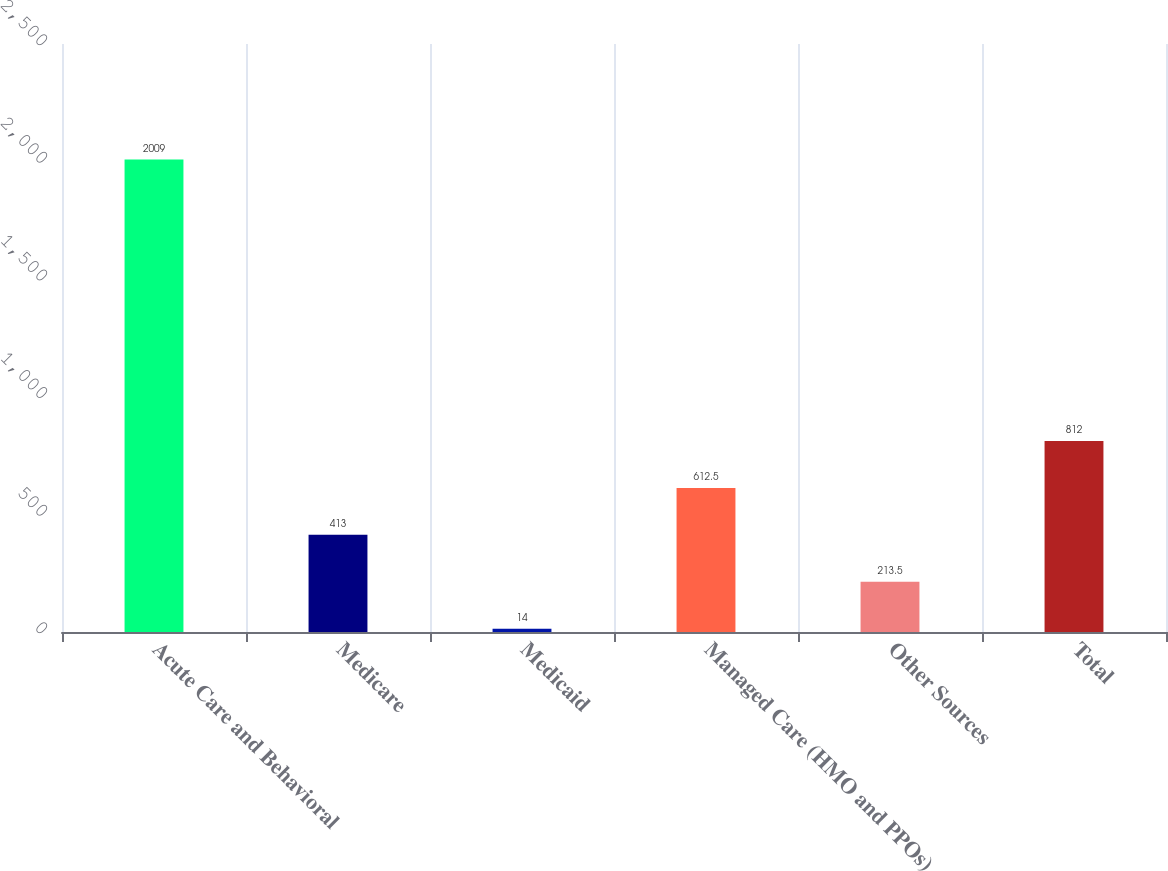Convert chart. <chart><loc_0><loc_0><loc_500><loc_500><bar_chart><fcel>Acute Care and Behavioral<fcel>Medicare<fcel>Medicaid<fcel>Managed Care (HMO and PPOs)<fcel>Other Sources<fcel>Total<nl><fcel>2009<fcel>413<fcel>14<fcel>612.5<fcel>213.5<fcel>812<nl></chart> 